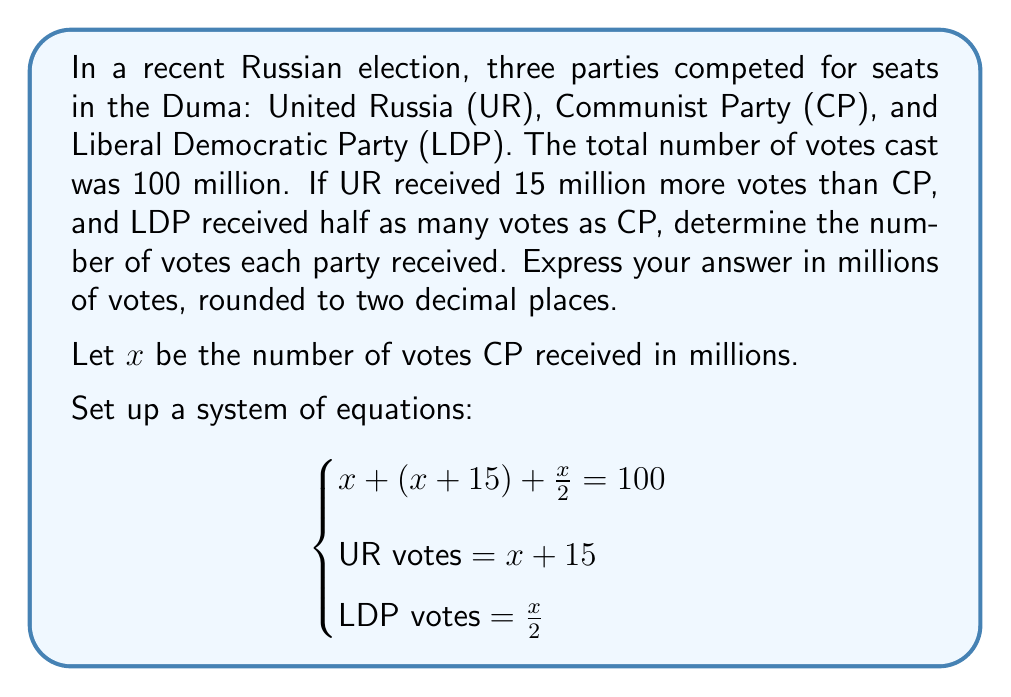Show me your answer to this math problem. Let's solve this system of equations step by step:

1) From the first equation:
   $$x + (x + 15) + \frac{x}{2} = 100$$

2) Simplify:
   $$x + x + 15 + \frac{x}{2} = 100$$
   $$2x + \frac{x}{2} + 15 = 100$$

3) Multiply all terms by 2 to eliminate fractions:
   $$4x + x + 30 = 200$$
   $$5x + 30 = 200$$

4) Subtract 30 from both sides:
   $$5x = 170$$

5) Divide both sides by 5:
   $$x = 34$$

Now that we know $x = 34$, we can calculate the votes for each party:

Communist Party (CP): $x = 34$ million votes

United Russia (UR): $x + 15 = 34 + 15 = 49$ million votes

Liberal Democratic Party (LDP): $\frac{x}{2} = \frac{34}{2} = 17$ million votes

We can verify that the total sum is correct:
$$34 + 49 + 17 = 100$$ million votes
Answer: Communist Party: 34.00 million votes
United Russia: 49.00 million votes
Liberal Democratic Party: 17.00 million votes 